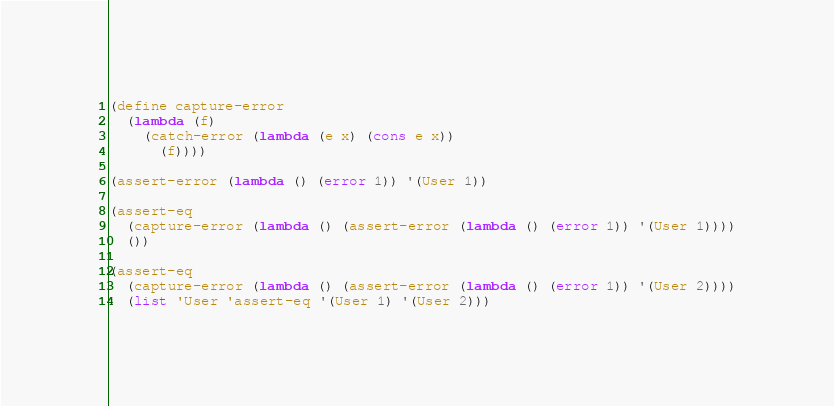Convert code to text. <code><loc_0><loc_0><loc_500><loc_500><_Lisp_>(define capture-error
  (lambda (f)
    (catch-error (lambda (e x) (cons e x))
      (f))))

(assert-error (lambda () (error 1)) '(User 1))

(assert-eq
  (capture-error (lambda () (assert-error (lambda () (error 1)) '(User 1))))
  ())

(assert-eq
  (capture-error (lambda () (assert-error (lambda () (error 1)) '(User 2))))
  (list 'User 'assert-eq '(User 1) '(User 2)))
</code> 